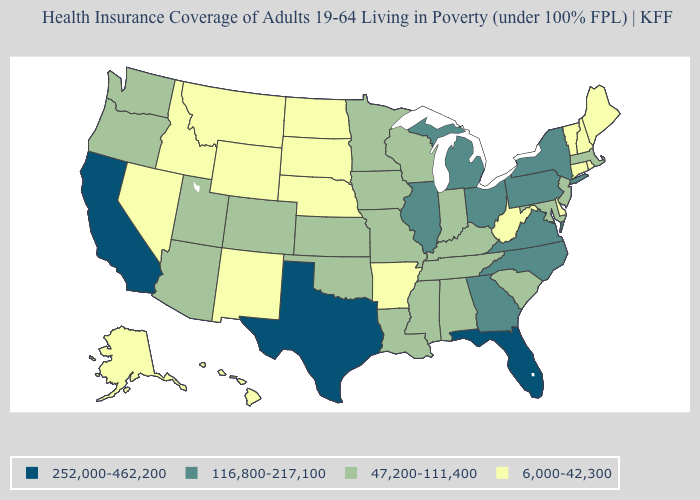What is the value of Alaska?
Short answer required. 6,000-42,300. Name the states that have a value in the range 47,200-111,400?
Give a very brief answer. Alabama, Arizona, Colorado, Indiana, Iowa, Kansas, Kentucky, Louisiana, Maryland, Massachusetts, Minnesota, Mississippi, Missouri, New Jersey, Oklahoma, Oregon, South Carolina, Tennessee, Utah, Washington, Wisconsin. Name the states that have a value in the range 47,200-111,400?
Answer briefly. Alabama, Arizona, Colorado, Indiana, Iowa, Kansas, Kentucky, Louisiana, Maryland, Massachusetts, Minnesota, Mississippi, Missouri, New Jersey, Oklahoma, Oregon, South Carolina, Tennessee, Utah, Washington, Wisconsin. What is the highest value in the USA?
Short answer required. 252,000-462,200. Among the states that border West Virginia , does Kentucky have the lowest value?
Write a very short answer. Yes. Which states have the lowest value in the USA?
Keep it brief. Alaska, Arkansas, Connecticut, Delaware, Hawaii, Idaho, Maine, Montana, Nebraska, Nevada, New Hampshire, New Mexico, North Dakota, Rhode Island, South Dakota, Vermont, West Virginia, Wyoming. Name the states that have a value in the range 116,800-217,100?
Quick response, please. Georgia, Illinois, Michigan, New York, North Carolina, Ohio, Pennsylvania, Virginia. What is the value of Minnesota?
Be succinct. 47,200-111,400. Does Colorado have a higher value than Delaware?
Concise answer only. Yes. Which states have the lowest value in the USA?
Be succinct. Alaska, Arkansas, Connecticut, Delaware, Hawaii, Idaho, Maine, Montana, Nebraska, Nevada, New Hampshire, New Mexico, North Dakota, Rhode Island, South Dakota, Vermont, West Virginia, Wyoming. What is the value of New Hampshire?
Answer briefly. 6,000-42,300. Does Florida have the highest value in the South?
Give a very brief answer. Yes. Name the states that have a value in the range 116,800-217,100?
Write a very short answer. Georgia, Illinois, Michigan, New York, North Carolina, Ohio, Pennsylvania, Virginia. Which states have the highest value in the USA?
Quick response, please. California, Florida, Texas. Does Virginia have the same value as Illinois?
Write a very short answer. Yes. 